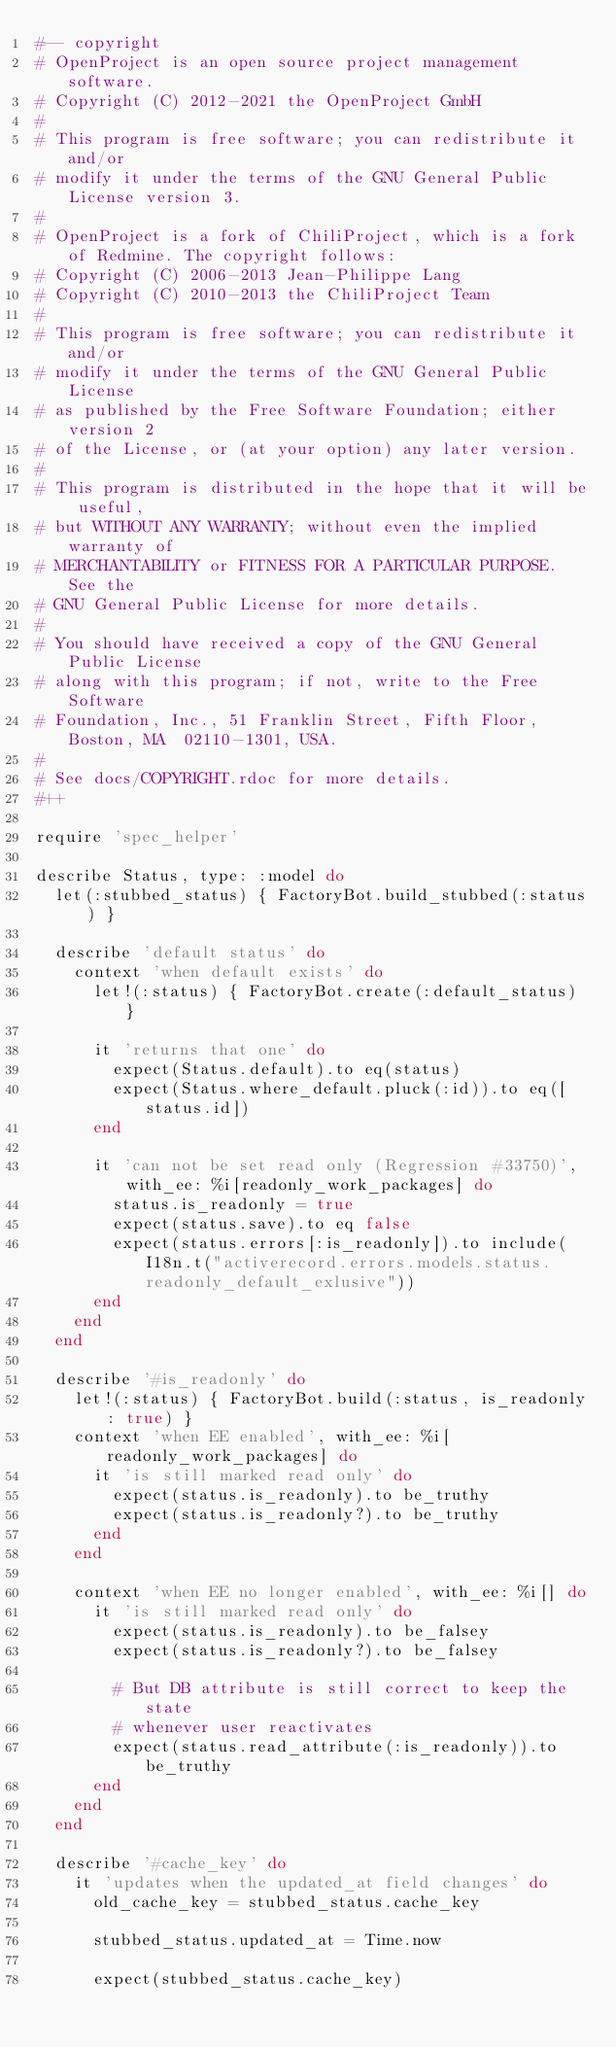<code> <loc_0><loc_0><loc_500><loc_500><_Ruby_>#-- copyright
# OpenProject is an open source project management software.
# Copyright (C) 2012-2021 the OpenProject GmbH
#
# This program is free software; you can redistribute it and/or
# modify it under the terms of the GNU General Public License version 3.
#
# OpenProject is a fork of ChiliProject, which is a fork of Redmine. The copyright follows:
# Copyright (C) 2006-2013 Jean-Philippe Lang
# Copyright (C) 2010-2013 the ChiliProject Team
#
# This program is free software; you can redistribute it and/or
# modify it under the terms of the GNU General Public License
# as published by the Free Software Foundation; either version 2
# of the License, or (at your option) any later version.
#
# This program is distributed in the hope that it will be useful,
# but WITHOUT ANY WARRANTY; without even the implied warranty of
# MERCHANTABILITY or FITNESS FOR A PARTICULAR PURPOSE.  See the
# GNU General Public License for more details.
#
# You should have received a copy of the GNU General Public License
# along with this program; if not, write to the Free Software
# Foundation, Inc., 51 Franklin Street, Fifth Floor, Boston, MA  02110-1301, USA.
#
# See docs/COPYRIGHT.rdoc for more details.
#++

require 'spec_helper'

describe Status, type: :model do
  let(:stubbed_status) { FactoryBot.build_stubbed(:status) }

  describe 'default status' do
    context 'when default exists' do
      let!(:status) { FactoryBot.create(:default_status) }

      it 'returns that one' do
        expect(Status.default).to eq(status)
        expect(Status.where_default.pluck(:id)).to eq([status.id])
      end

      it 'can not be set read only (Regression #33750)', with_ee: %i[readonly_work_packages] do
        status.is_readonly = true
        expect(status.save).to eq false
        expect(status.errors[:is_readonly]).to include(I18n.t("activerecord.errors.models.status.readonly_default_exlusive"))
      end
    end
  end

  describe '#is_readonly' do
    let!(:status) { FactoryBot.build(:status, is_readonly: true) }
    context 'when EE enabled', with_ee: %i[readonly_work_packages] do
      it 'is still marked read only' do
        expect(status.is_readonly).to be_truthy
        expect(status.is_readonly?).to be_truthy
      end
    end

    context 'when EE no longer enabled', with_ee: %i[] do
      it 'is still marked read only' do
        expect(status.is_readonly).to be_falsey
        expect(status.is_readonly?).to be_falsey

        # But DB attribute is still correct to keep the state
        # whenever user reactivates
        expect(status.read_attribute(:is_readonly)).to be_truthy
      end
    end
  end

  describe '#cache_key' do
    it 'updates when the updated_at field changes' do
      old_cache_key = stubbed_status.cache_key

      stubbed_status.updated_at = Time.now

      expect(stubbed_status.cache_key)</code> 